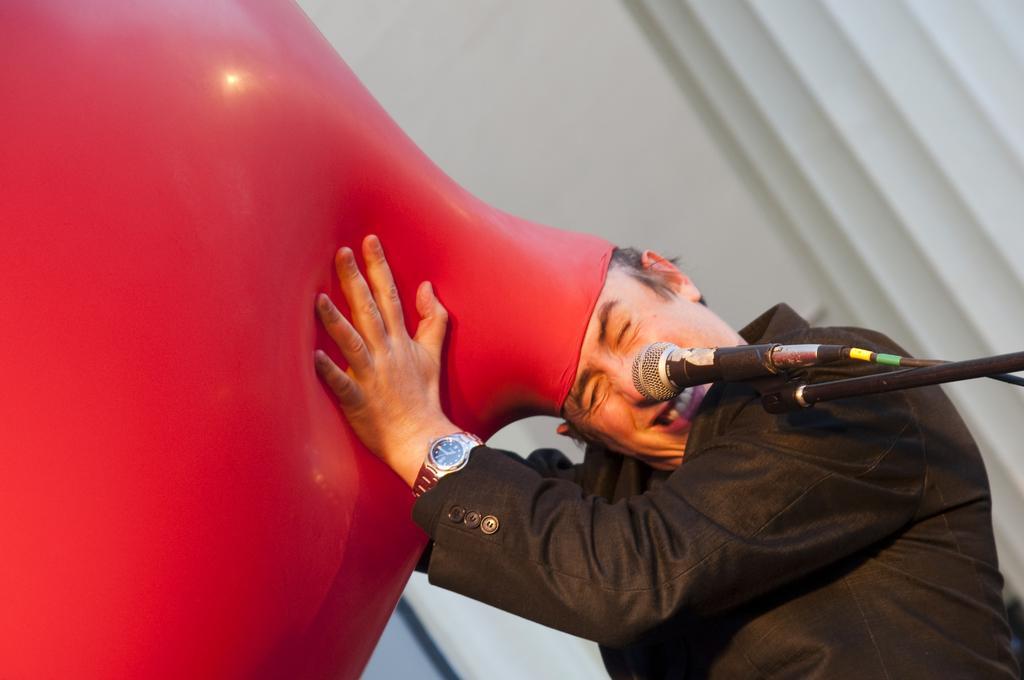Can you describe this image briefly? Bottom right side of the image a man is standing and holding a balloon. Behind him there is a wall and there is a microphone. 